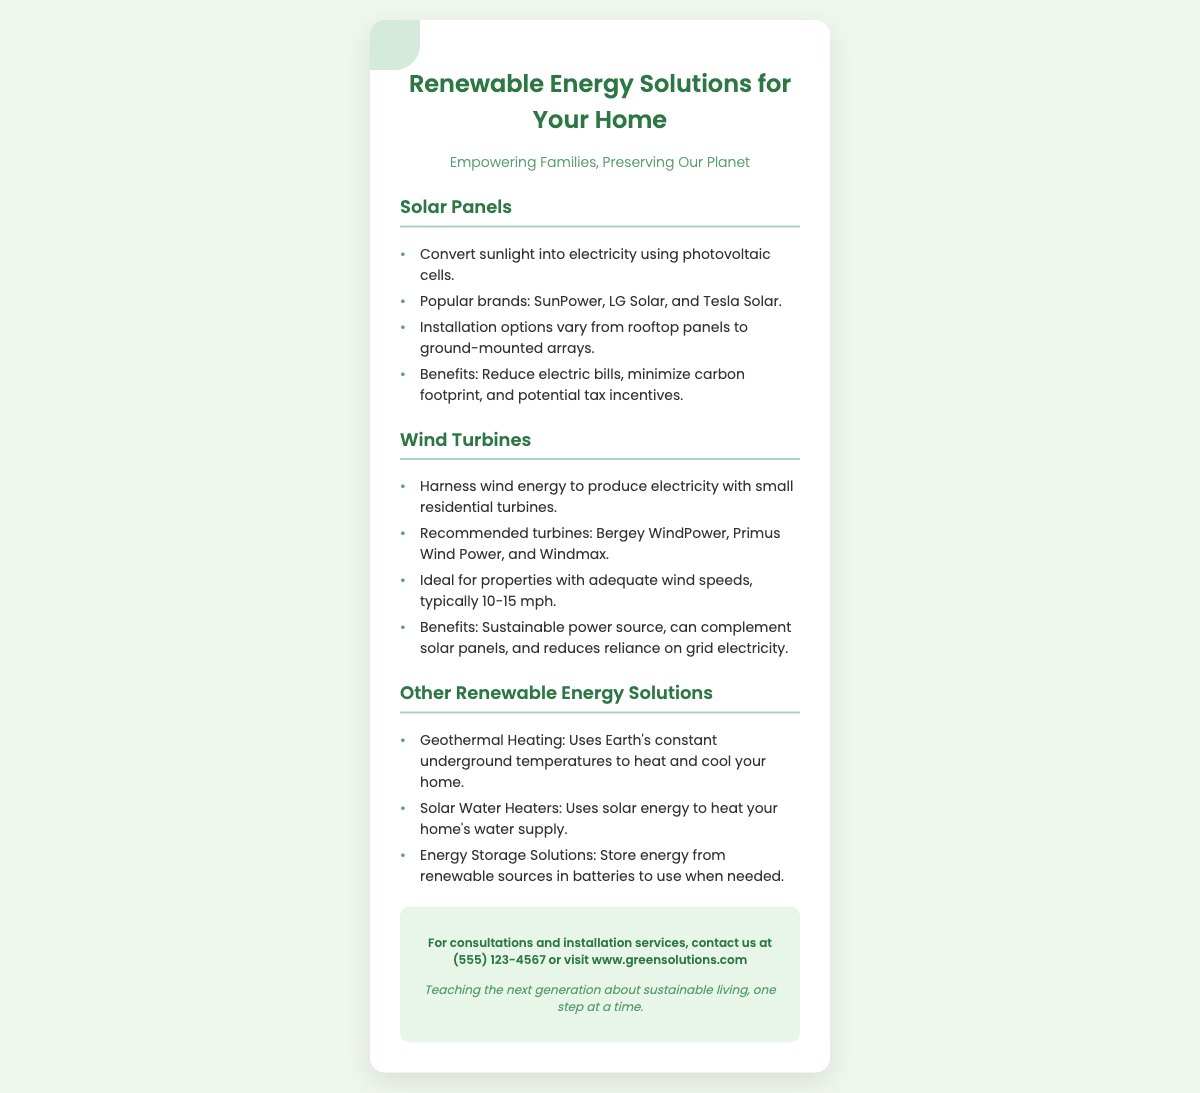What is the primary focus of the document? The document highlights renewable energy options for homes while emphasizing their benefits for families and the planet.
Answer: Renewable Energy Solutions for Your Home What are the three main types of renewable energy solutions mentioned? The document lists solar panels, wind turbines, and other renewable energy options.
Answer: Solar Panels, Wind Turbines, Other Renewable Energy Solutions Which brand is associated with solar panels? The document provides examples of popular brands for solar panels, highlighting one as a case study.
Answer: SunPower What is the typical wind speed required for residential wind turbines? The document states the ideal wind speeds for wind turbines to function efficiently.
Answer: 10-15 mph What advantage do solar panels provide according to the document? The document outlines several benefits of using solar panels for a household's energy needs.
Answer: Reduce electric bills Which technology uses the Earth’s underground temperatures? The document identifies specific technologies for renewable energy solutions, including one that uses geothermal sources.
Answer: Geothermal Heating What is included in the contact information section of the business card? The document specifies how to reach out for consultations or services, detailing contact options vividly.
Answer: (555) 123-4567 How does the document emphasize the importance of teaching children? The document concludes with a note that reflects a commitment to education about sustainable practices for the next generation.
Answer: Teaching the next generation about sustainable living 